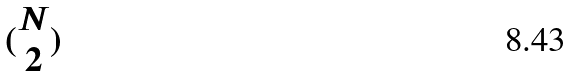<formula> <loc_0><loc_0><loc_500><loc_500>( \begin{matrix} N \\ 2 \end{matrix} )</formula> 